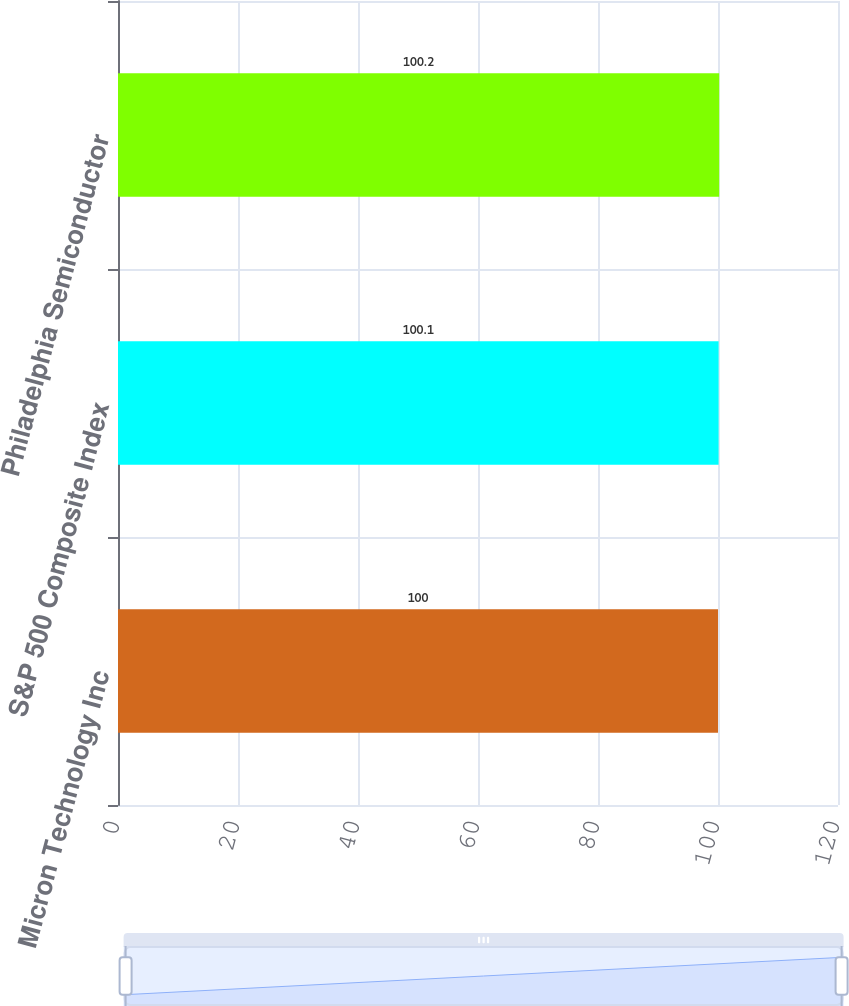<chart> <loc_0><loc_0><loc_500><loc_500><bar_chart><fcel>Micron Technology Inc<fcel>S&P 500 Composite Index<fcel>Philadelphia Semiconductor<nl><fcel>100<fcel>100.1<fcel>100.2<nl></chart> 